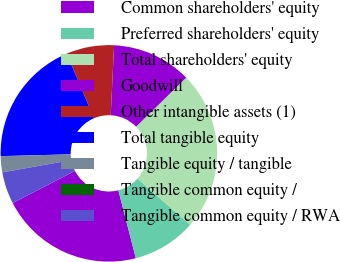<chart> <loc_0><loc_0><loc_500><loc_500><pie_chart><fcel>Common shareholders' equity<fcel>Preferred shareholders' equity<fcel>Total shareholders' equity<fcel>Goodwill<fcel>Other intangible assets (1)<fcel>Total tangible equity<fcel>Tangible equity / tangible<fcel>Tangible common equity /<fcel>Tangible common equity / RWA<nl><fcel>21.42%<fcel>9.52%<fcel>23.8%<fcel>11.9%<fcel>7.14%<fcel>19.04%<fcel>2.39%<fcel>0.02%<fcel>4.77%<nl></chart> 